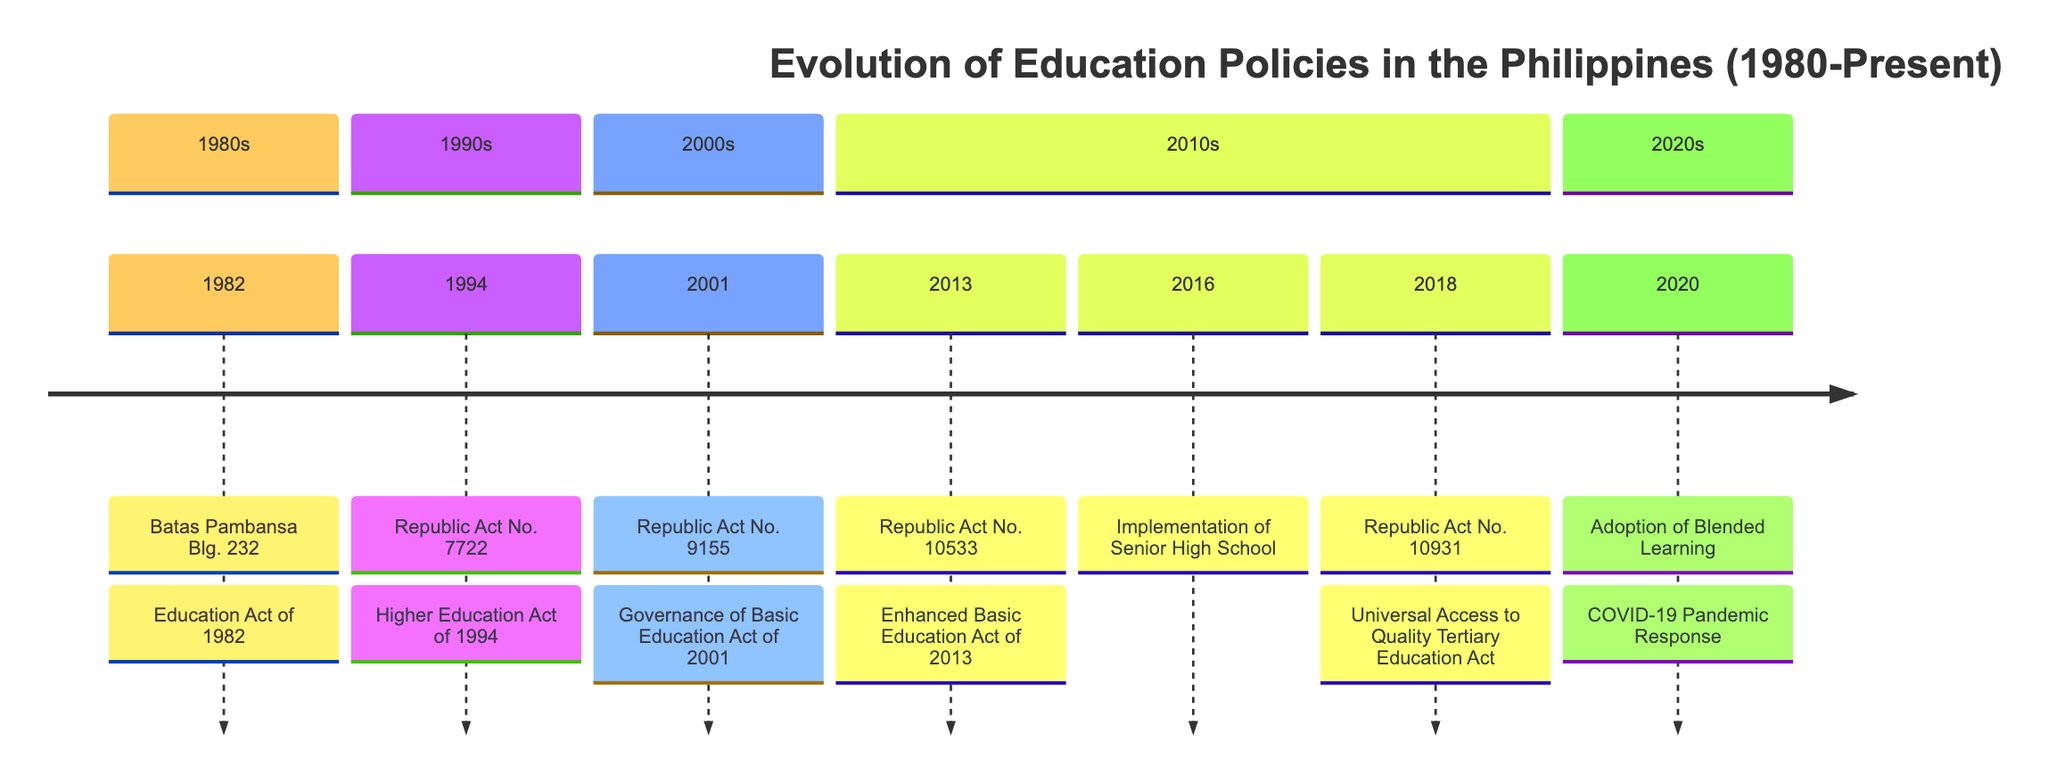What year was the Education Act of 1982 enacted? The timeline shows that the event "Batas Pambansa Blg. 232" is marked in the year 1982, indicating that this is the year the Education Act was enacted.
Answer: 1982 What significant event occurred in 2013? According to the timeline, the event listed for the year 2013 is "Republic Act No. 10533," which is the Enhanced Basic Education Act of 2013, thus identifying it as a significant event for that year.
Answer: Republic Act No. 10533 How many education-related events are listed for the 2010s? Counting the events in the timeline section for the 2010s, there are three specific events: the Enhanced Basic Education Act of 2013, the Implementation of Senior High School in 2016, and the Universal Access to Quality Tertiary Education Act in 2018.
Answer: 3 What act was established to focus on tertiary education in 1994? The timeline indicates that the "Republic Act No. 7722" is the act focused on higher education in 1994, thus it’s the correct reference for this question.
Answer: Republic Act No. 7722 Which act was implemented as a response to the COVID-19 pandemic? The timeline states that the event regarding the "Adoption of Blended Learning" occurred in 2020, specifically mentioning its connection to the COVID-19 pandemic and the changes it necessitated in education.
Answer: Adoption of Blended Learning What is the relationship between the 1982 Education Act and the bilingual education policy? Reviewing the descriptive information provided for the event "Batas Pambansa Blg. 232," it notes that this act implemented a bilingual education policy, establishing a direct relationship between the two.
Answer: Implemented the bilingual education policy Which year signifies the start of the nationwide implementation of Senior High School? The timeline specifies that the implementation of Senior High School started in the year 2016, marking it as a significant educational milestone.
Answer: 2016 What major change was introduced by the Governance of Basic Education Act of 2001? The event "Republic Act No. 9155," noted in the timeline for the year 2001, reveals that a significant change was the renaming of DECS to DepEd and decentralizing administrative decision-making.
Answer: Renamed DECS to DepEd and decentralized decision-making 